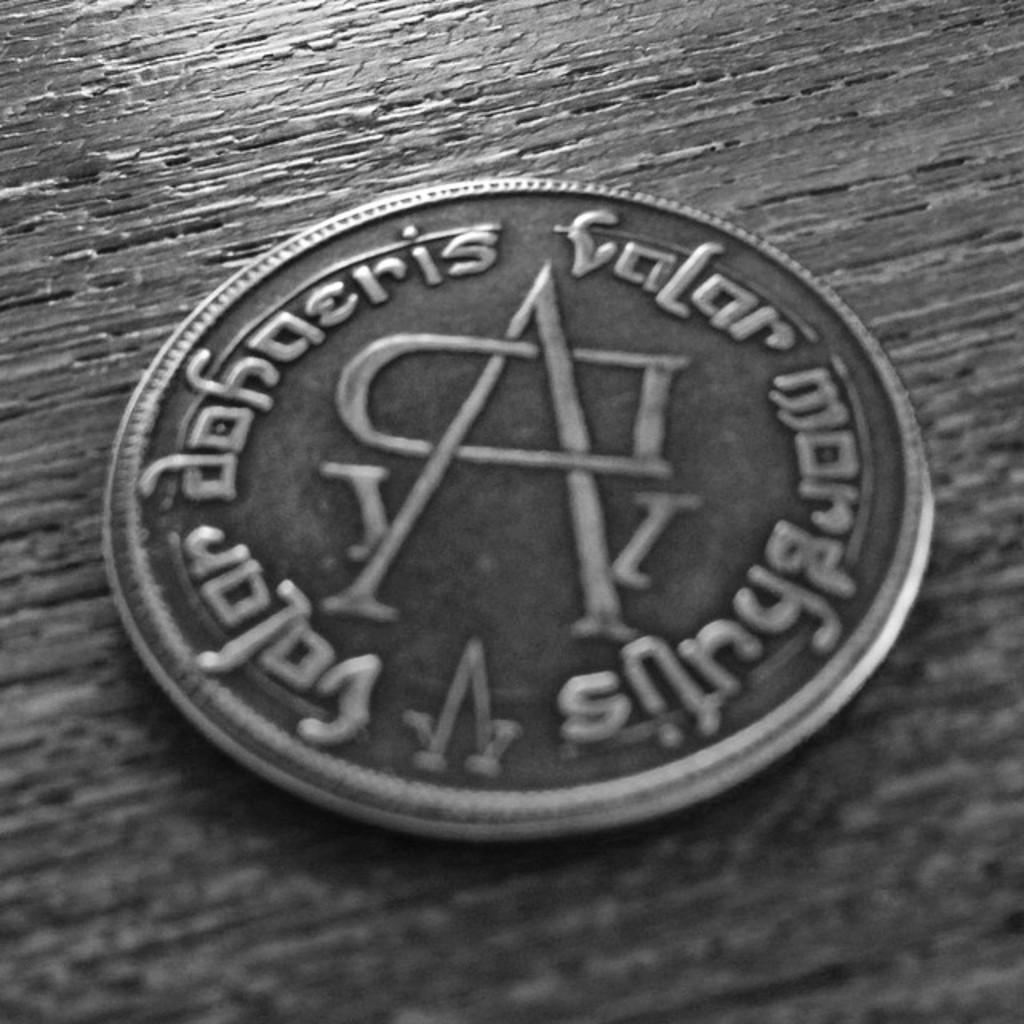Provide a one-sentence caption for the provided image. A coin sits on a wooden table, the writing on it is foreign, but the letters A and D sit in the middle. 